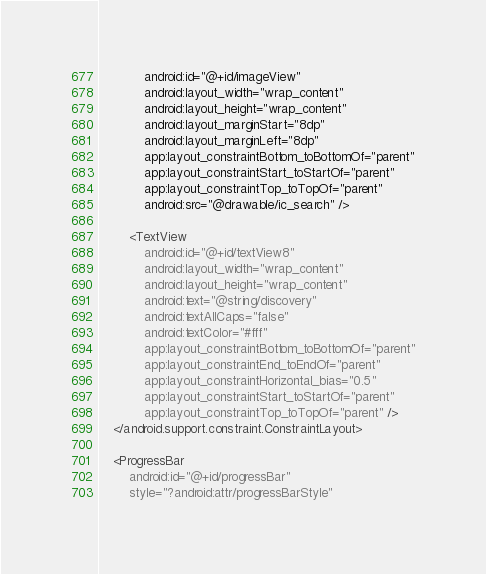<code> <loc_0><loc_0><loc_500><loc_500><_XML_>            android:id="@+id/imageView"
            android:layout_width="wrap_content"
            android:layout_height="wrap_content"
            android:layout_marginStart="8dp"
            android:layout_marginLeft="8dp"
            app:layout_constraintBottom_toBottomOf="parent"
            app:layout_constraintStart_toStartOf="parent"
            app:layout_constraintTop_toTopOf="parent"
            android:src="@drawable/ic_search" />

        <TextView
            android:id="@+id/textView8"
            android:layout_width="wrap_content"
            android:layout_height="wrap_content"
            android:text="@string/discovery"
            android:textAllCaps="false"
            android:textColor="#fff"
            app:layout_constraintBottom_toBottomOf="parent"
            app:layout_constraintEnd_toEndOf="parent"
            app:layout_constraintHorizontal_bias="0.5"
            app:layout_constraintStart_toStartOf="parent"
            app:layout_constraintTop_toTopOf="parent" />
    </android.support.constraint.ConstraintLayout>

    <ProgressBar
        android:id="@+id/progressBar"
        style="?android:attr/progressBarStyle"</code> 